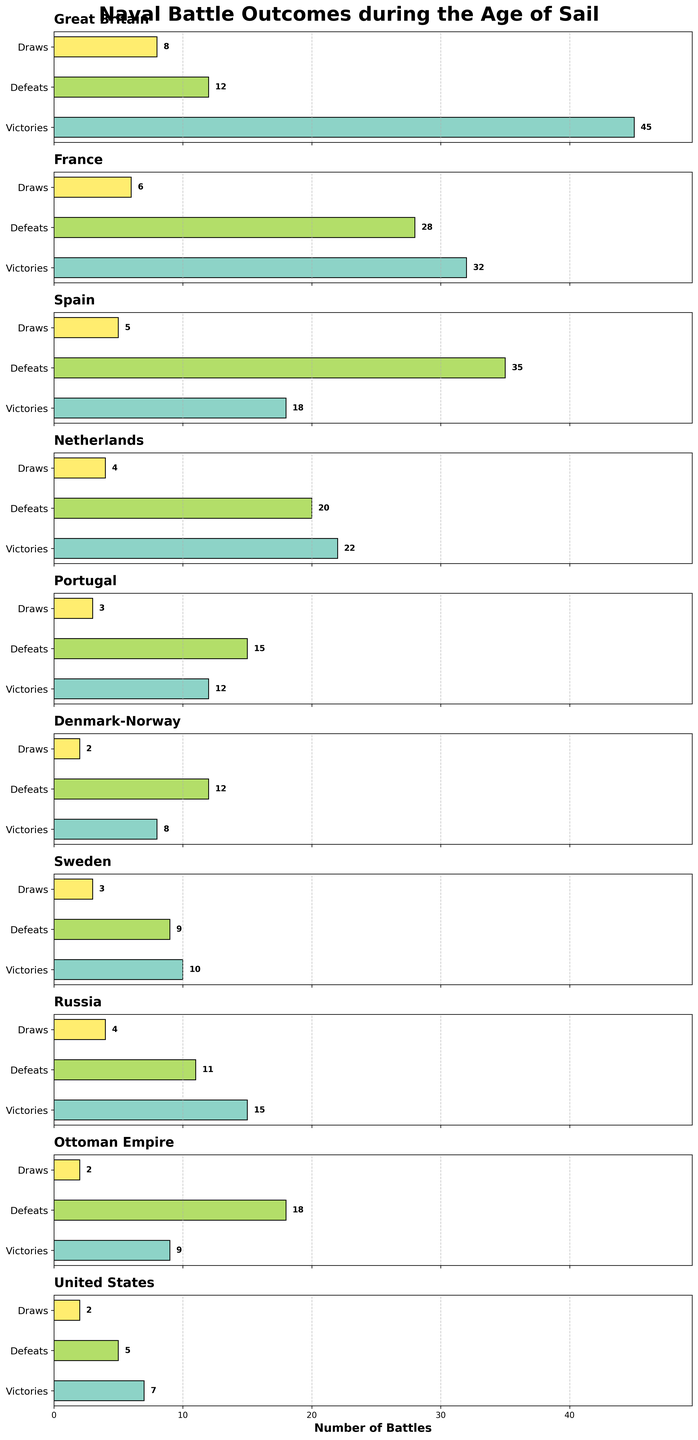What's the total number of battles involving Great Britain? The categories for Great Britain are 45 victories, 12 defeats, and 8 draws. Adding these together gives 45 + 12 + 8.
Answer: 65 Which country has the most victories in naval battles? The countries and their victories are shown in the figure. Great Britain has the highest number of victories (45).
Answer: Great Britain Among France and Spain, which country has a higher proportion of draws to total battles? France has 32 victories, 28 defeats, and 6 draws, totaling 66 battles. Spain has 18 victories, 35 defeats, and 5 draws, totaling 58 battles. The proportions are 6/66 for France and 5/58 for Spain. Calculating these gives approximately 0.09 for France and 0.086 for Spain.
Answer: France What is the combined number of victories and draws for Denmark-Norway? Denmark-Norway has 8 victories and 2 draws. Adding these together gives 8 + 2.
Answer: 10 Which country has the fewest defeats, and how many are there? The defeats for each country are shown in the figure. The United States has the fewest defeats with 5.
Answer: United States Are there any countries with an equal number of victories and defeats? The figure shows the number of victories and defeats for each country. The Netherlands has 22 victories and 20 defeats, which are the closest, but they are not equal. No country has equal victories and defeats.
Answer: No What is the average number of victories across all countries? Adding the victories for all countries and dividing by the number of countries (45 + 32 + 18 + 22 + 12 + 8 + 10 + 15 + 9 + 7)/10 gives 178/10.
Answer: 17.8 If you sum the number of draws for Russia and the Ottoman Empire, what do you get? Russia has 4 draws, and the Ottoman Empire has 2 draws. Adding these gives 4 + 2.
Answer: 6 How many more victories does Sweden have compared to the United States? Sweden has 10 victories, and the United States has 7 victories. The difference is 10 - 7.
Answer: 3 Which country's bar representing defeats is the longest (i.e., has the highest number of defeats)? The figure shows the number of defeats for each country. Spain has the highest number of defeats with 35.
Answer: Spain 